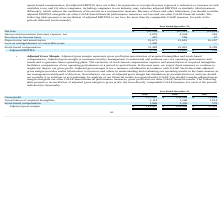According to Everbridge's financial document, What does the Adjusted EBITDA represent? Based on the financial document, the answer is Adjusted EBITDA represents our net loss before interest and investment income, net and interest expense, provision for income taxes, depreciation and amortization expense, loss on extinguishment of convertible notes and stock-based compensation expense. Also, What are the non-cash items included in Adjusted EBITDA? Based on the financial document, the answer is depreciation and amortization expense and stock-based compensation expense.. Also, What was the Net Loss in 2019, 2018 and 2017 respectively? The document contains multiple relevant values: (52,250), (47,515), (19,634) (in thousands). From the document: "Net loss $ (52,250) $ (47,515) $ (19,634) Net loss $ (52,250) $ (47,515) $ (19,634) Net loss $ (52,250) $ (47,515) $ (19,634)..." Additionally, Which year has the highest adjusted EBITDA? According to the financial document, 2019. The relevant text states: "2019 2018 2017..." Also, can you calculate: What is the average Interest and investment (income) expense, net for 2017-2019? To answer this question, I need to perform calculations using the financial data. The calculation is: (2,979 + 4,504 + 216) / 3, which equals 2566.33 (in thousands). This is based on the information: "and investment (income) expense, net 2,979 4,504 216 Interest and investment (income) expense, net 2,979 4,504 216 terest and investment (income) expense, net 2,979 4,504 216..." The key data points involved are: 2,979, 216, 4,504. Also, can you calculate: What is the change in the Provision for income taxes from 2018 to 2019? Based on the calculation: 425 - 796, the result is -371 (in thousands). This is based on the information: "Provision for income taxes 425 796 47 Provision for income taxes 425 796 47..." The key data points involved are: 425, 796. 